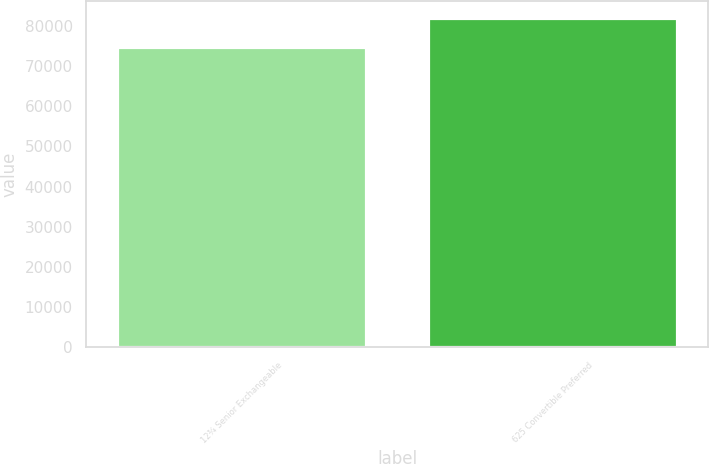Convert chart to OTSL. <chart><loc_0><loc_0><loc_500><loc_500><bar_chart><fcel>12¾ Senior Exchangeable<fcel>625 Convertible Preferred<nl><fcel>74788<fcel>82010<nl></chart> 